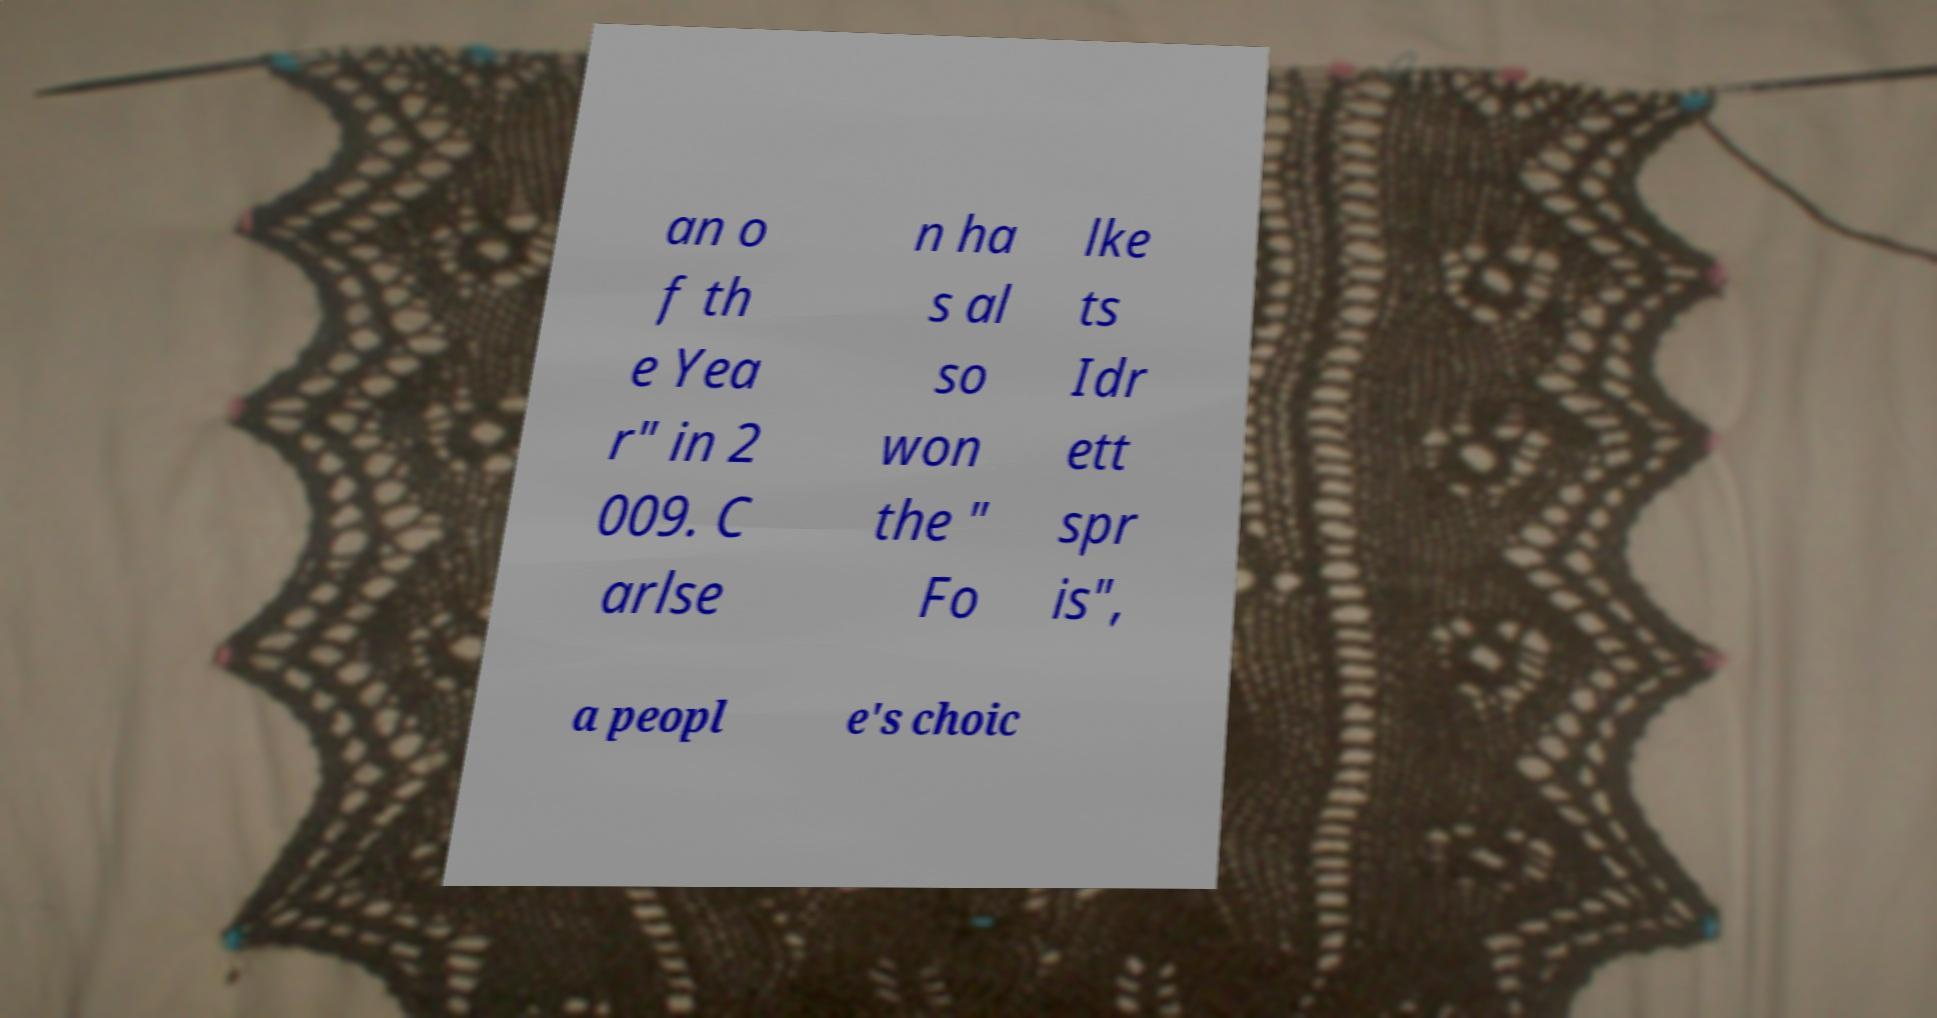For documentation purposes, I need the text within this image transcribed. Could you provide that? an o f th e Yea r" in 2 009. C arlse n ha s al so won the " Fo lke ts Idr ett spr is", a peopl e's choic 